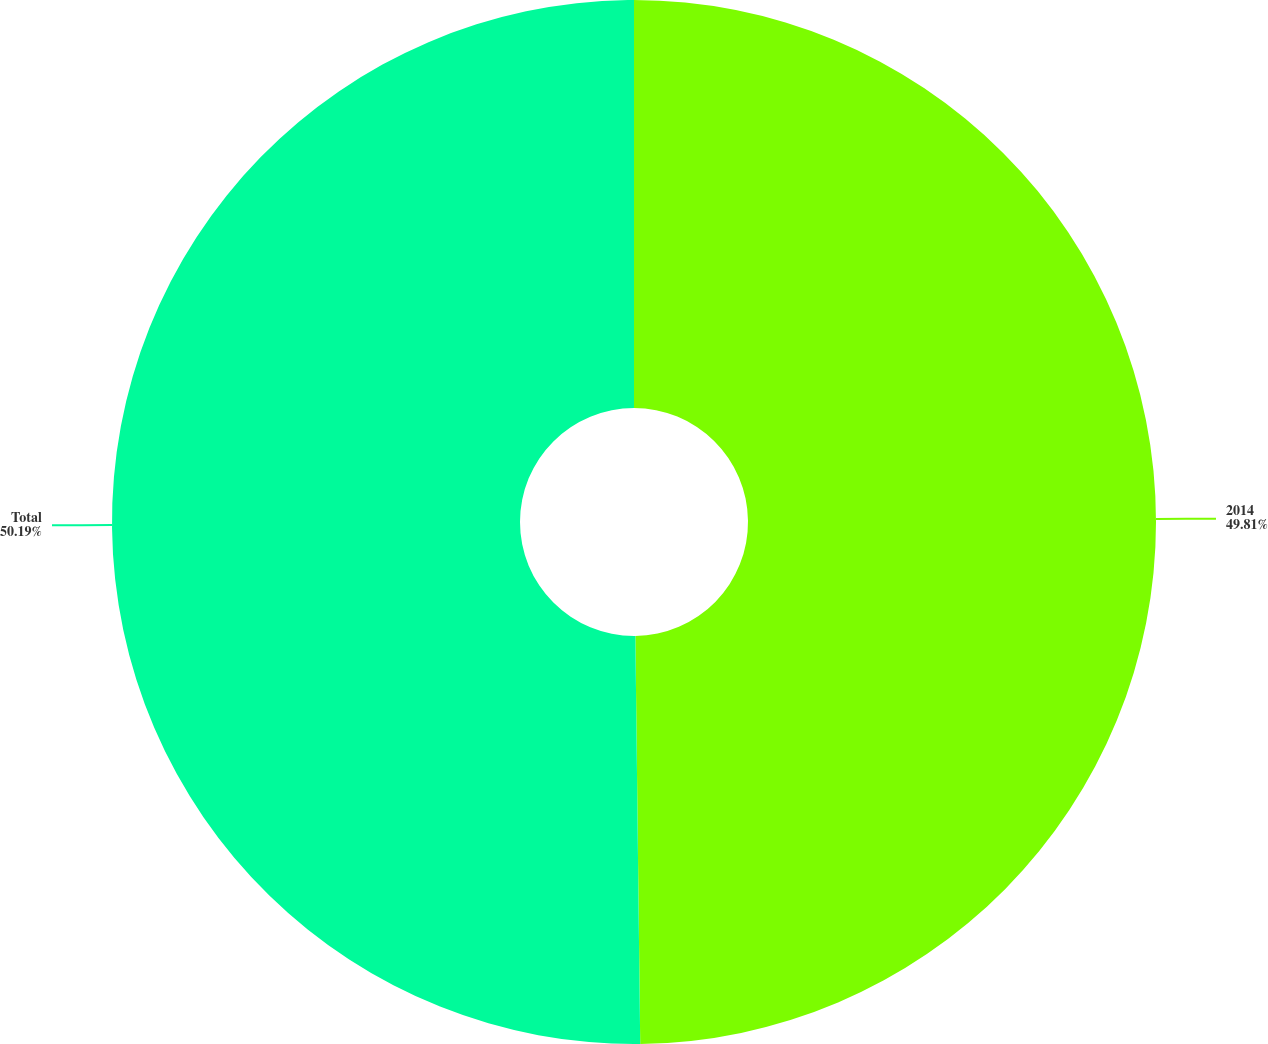<chart> <loc_0><loc_0><loc_500><loc_500><pie_chart><fcel>2014<fcel>Total<nl><fcel>49.81%<fcel>50.19%<nl></chart> 